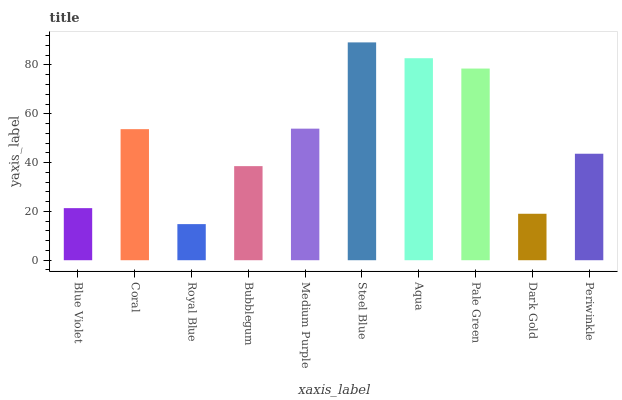Is Royal Blue the minimum?
Answer yes or no. Yes. Is Steel Blue the maximum?
Answer yes or no. Yes. Is Coral the minimum?
Answer yes or no. No. Is Coral the maximum?
Answer yes or no. No. Is Coral greater than Blue Violet?
Answer yes or no. Yes. Is Blue Violet less than Coral?
Answer yes or no. Yes. Is Blue Violet greater than Coral?
Answer yes or no. No. Is Coral less than Blue Violet?
Answer yes or no. No. Is Coral the high median?
Answer yes or no. Yes. Is Periwinkle the low median?
Answer yes or no. Yes. Is Royal Blue the high median?
Answer yes or no. No. Is Coral the low median?
Answer yes or no. No. 